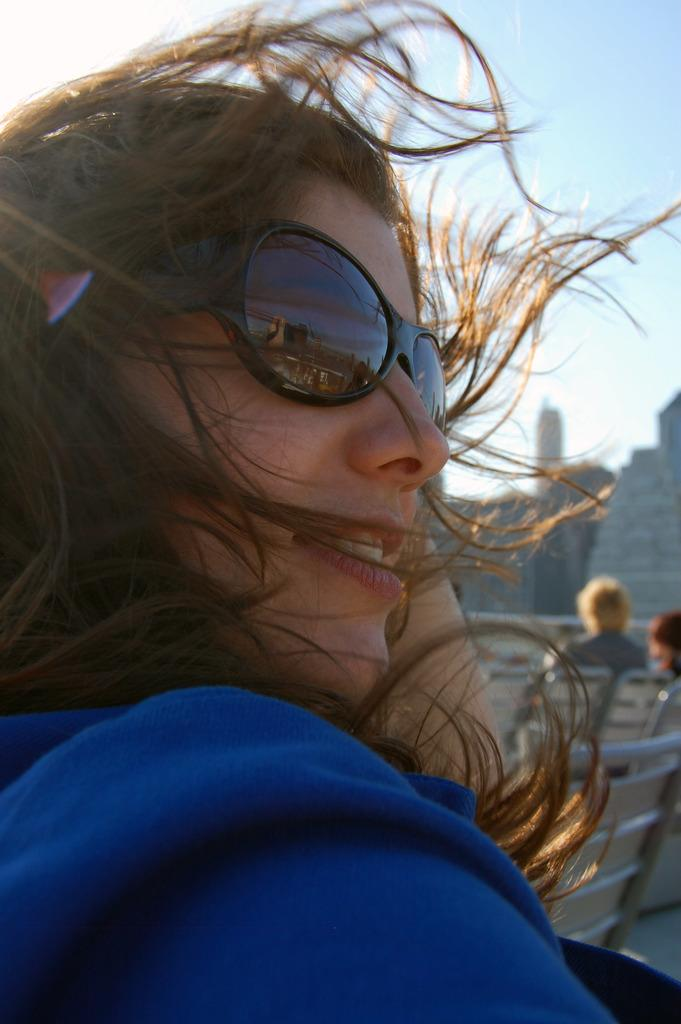What is the main subject in the foreground of the image? There is a woman in the foreground of the image. What is the woman wearing on her face? The woman is wearing black spectacles. What color is the dress the woman is wearing? The woman is wearing a blue dress. What type of game is the woman playing in the image? There is no game present in the image; it only features a woman wearing black spectacles and a blue dress. What arithmetic problem is the woman solving in the image? There is no arithmetic problem present in the image; it only features a woman wearing black spectacles and a blue dress. 